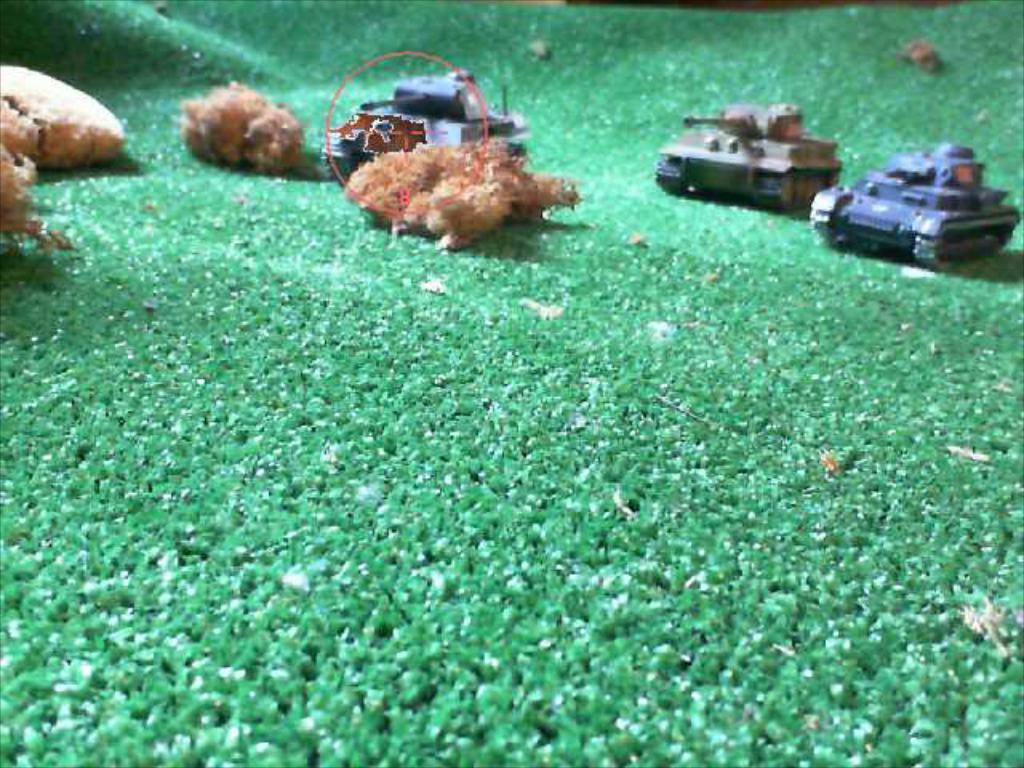Describe this image in one or two sentences. In this image I can see three toy vehicles and few brown color objects on the green color floor. 